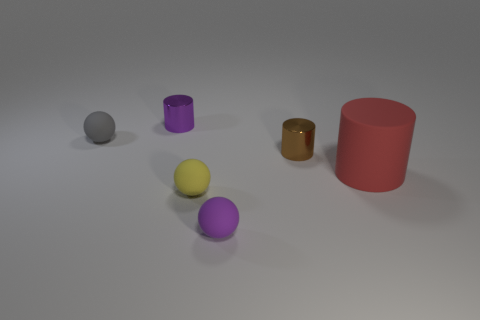Add 4 red rubber objects. How many objects exist? 10 Subtract all small metal objects. Subtract all red cylinders. How many objects are left? 3 Add 6 small purple cylinders. How many small purple cylinders are left? 7 Add 5 small blue shiny spheres. How many small blue shiny spheres exist? 5 Subtract 0 gray blocks. How many objects are left? 6 